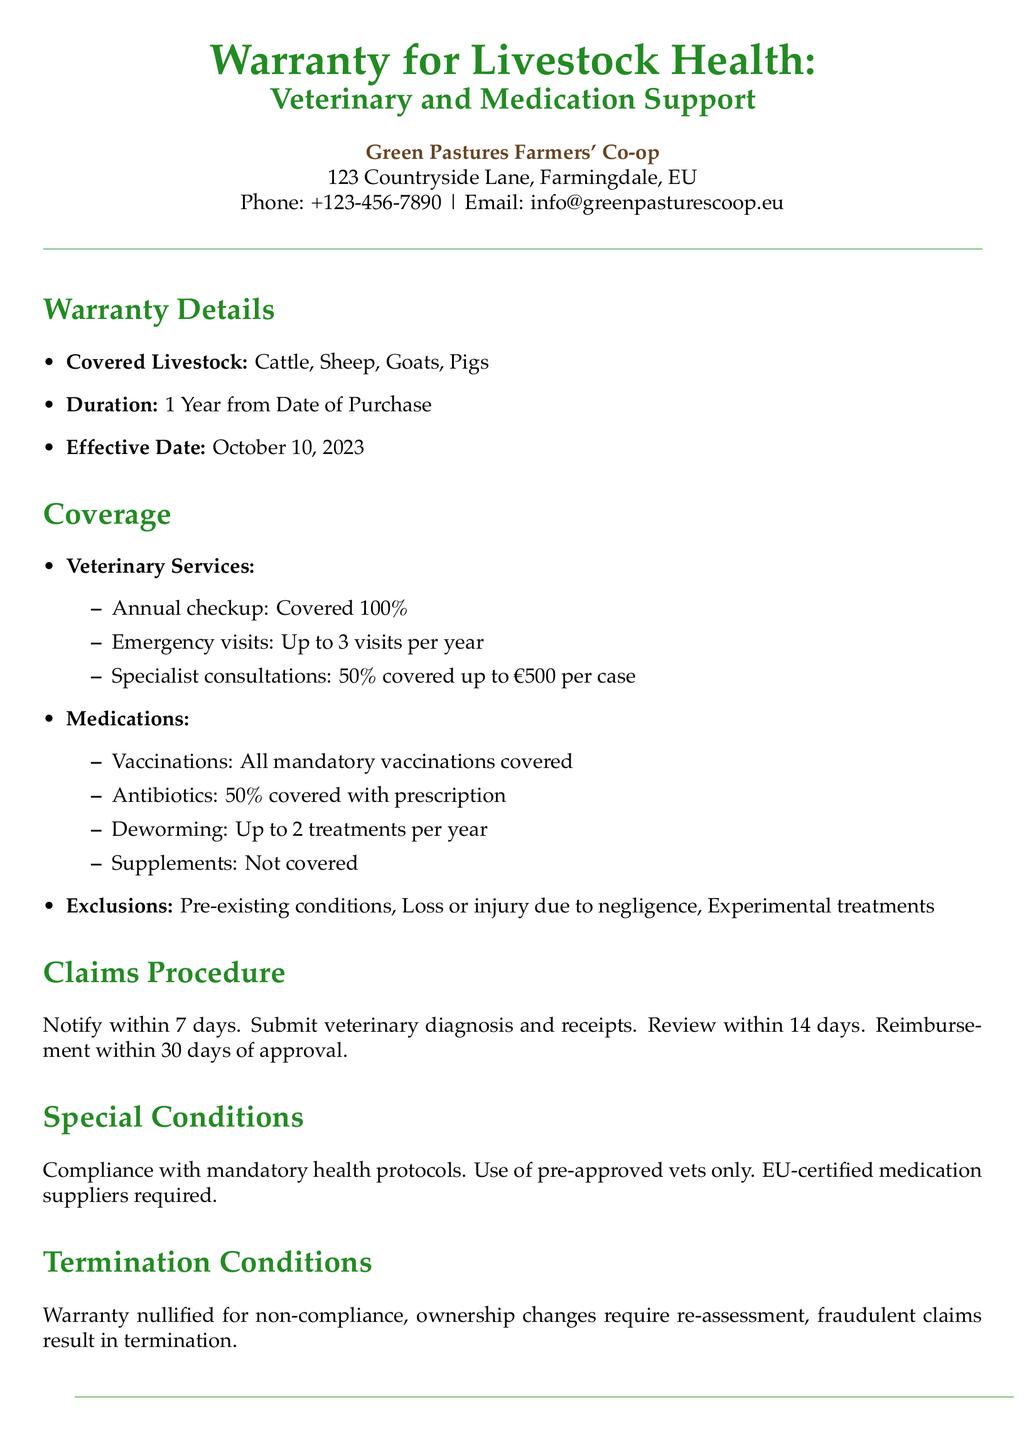what is the effective date of the warranty? The effective date is the starting point of the warranty coverage mentioned in the document.
Answer: October 10, 2023 which livestock are covered under this warranty? The document specifies which types of livestock are included in the coverage.
Answer: Cattle, Sheep, Goats, Pigs what percentage of annual checkups is covered? The coverage details indicate the extent of coverage for specific veterinary services.
Answer: 100% how many emergency visits are covered per year? The document states the limit on the number of emergency visits allowed under the warranty.
Answer: Up to 3 visits per year what is the coverage for specialist consultations? Understanding the specifics of veterinary service coverage is important for medical support.
Answer: 50% covered up to €500 per case are supplements covered under this warranty? The document lists items that are not covered, including specific treatments.
Answer: Not covered what happens if there is non-compliance with the warranty conditions? This question addresses the implications of failing to follow the warranty terms outlined.
Answer: Warranty nullified how long do I have to notify about a claim? This is key for understanding the timeframe for submitting a claim under the warranty.
Answer: 7 days who is the authorized representative of the co-op? Knowing the contact person in case of issues or questions is essential in a warranty context.
Answer: John Farmersworth what is the duration of the warranty? The document specifies how long the warranty coverage lasts after purchase.
Answer: 1 Year from Date of Purchase 